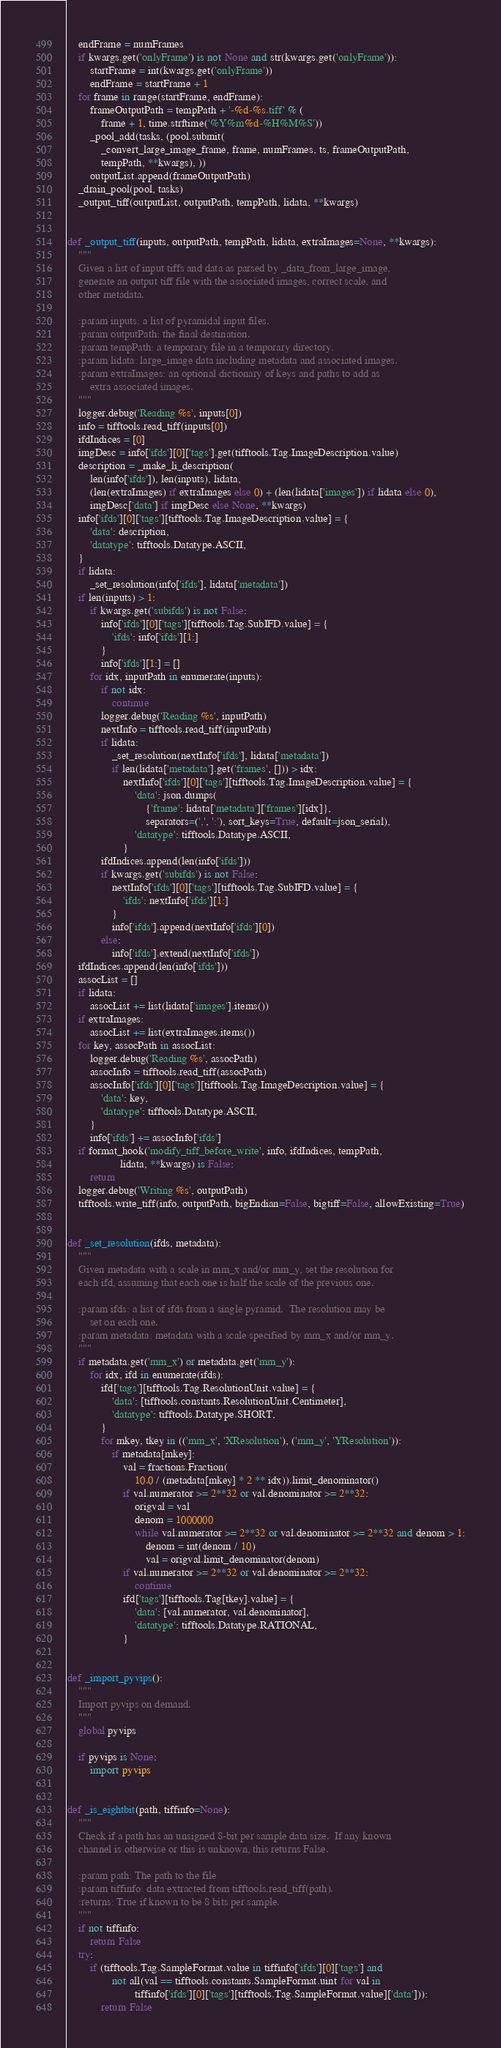Convert code to text. <code><loc_0><loc_0><loc_500><loc_500><_Python_>    endFrame = numFrames
    if kwargs.get('onlyFrame') is not None and str(kwargs.get('onlyFrame')):
        startFrame = int(kwargs.get('onlyFrame'))
        endFrame = startFrame + 1
    for frame in range(startFrame, endFrame):
        frameOutputPath = tempPath + '-%d-%s.tiff' % (
            frame + 1, time.strftime('%Y%m%d-%H%M%S'))
        _pool_add(tasks, (pool.submit(
            _convert_large_image_frame, frame, numFrames, ts, frameOutputPath,
            tempPath, **kwargs), ))
        outputList.append(frameOutputPath)
    _drain_pool(pool, tasks)
    _output_tiff(outputList, outputPath, tempPath, lidata, **kwargs)


def _output_tiff(inputs, outputPath, tempPath, lidata, extraImages=None, **kwargs):
    """
    Given a list of input tiffs and data as parsed by _data_from_large_image,
    generate an output tiff file with the associated images, correct scale, and
    other metadata.

    :param inputs: a list of pyramidal input files.
    :param outputPath: the final destination.
    :param tempPath: a temporary file in a temporary directory.
    :param lidata: large_image data including metadata and associated images.
    :param extraImages: an optional dictionary of keys and paths to add as
        extra associated images.
    """
    logger.debug('Reading %s', inputs[0])
    info = tifftools.read_tiff(inputs[0])
    ifdIndices = [0]
    imgDesc = info['ifds'][0]['tags'].get(tifftools.Tag.ImageDescription.value)
    description = _make_li_description(
        len(info['ifds']), len(inputs), lidata,
        (len(extraImages) if extraImages else 0) + (len(lidata['images']) if lidata else 0),
        imgDesc['data'] if imgDesc else None, **kwargs)
    info['ifds'][0]['tags'][tifftools.Tag.ImageDescription.value] = {
        'data': description,
        'datatype': tifftools.Datatype.ASCII,
    }
    if lidata:
        _set_resolution(info['ifds'], lidata['metadata'])
    if len(inputs) > 1:
        if kwargs.get('subifds') is not False:
            info['ifds'][0]['tags'][tifftools.Tag.SubIFD.value] = {
                'ifds': info['ifds'][1:]
            }
            info['ifds'][1:] = []
        for idx, inputPath in enumerate(inputs):
            if not idx:
                continue
            logger.debug('Reading %s', inputPath)
            nextInfo = tifftools.read_tiff(inputPath)
            if lidata:
                _set_resolution(nextInfo['ifds'], lidata['metadata'])
                if len(lidata['metadata'].get('frames', [])) > idx:
                    nextInfo['ifds'][0]['tags'][tifftools.Tag.ImageDescription.value] = {
                        'data': json.dumps(
                            {'frame': lidata['metadata']['frames'][idx]},
                            separators=(',', ':'), sort_keys=True, default=json_serial),
                        'datatype': tifftools.Datatype.ASCII,
                    }
            ifdIndices.append(len(info['ifds']))
            if kwargs.get('subifds') is not False:
                nextInfo['ifds'][0]['tags'][tifftools.Tag.SubIFD.value] = {
                    'ifds': nextInfo['ifds'][1:]
                }
                info['ifds'].append(nextInfo['ifds'][0])
            else:
                info['ifds'].extend(nextInfo['ifds'])
    ifdIndices.append(len(info['ifds']))
    assocList = []
    if lidata:
        assocList += list(lidata['images'].items())
    if extraImages:
        assocList += list(extraImages.items())
    for key, assocPath in assocList:
        logger.debug('Reading %s', assocPath)
        assocInfo = tifftools.read_tiff(assocPath)
        assocInfo['ifds'][0]['tags'][tifftools.Tag.ImageDescription.value] = {
            'data': key,
            'datatype': tifftools.Datatype.ASCII,
        }
        info['ifds'] += assocInfo['ifds']
    if format_hook('modify_tiff_before_write', info, ifdIndices, tempPath,
                   lidata, **kwargs) is False:
        return
    logger.debug('Writing %s', outputPath)
    tifftools.write_tiff(info, outputPath, bigEndian=False, bigtiff=False, allowExisting=True)


def _set_resolution(ifds, metadata):
    """
    Given metadata with a scale in mm_x and/or mm_y, set the resolution for
    each ifd, assuming that each one is half the scale of the previous one.

    :param ifds: a list of ifds from a single pyramid.  The resolution may be
        set on each one.
    :param metadata: metadata with a scale specified by mm_x and/or mm_y.
    """
    if metadata.get('mm_x') or metadata.get('mm_y'):
        for idx, ifd in enumerate(ifds):
            ifd['tags'][tifftools.Tag.ResolutionUnit.value] = {
                'data': [tifftools.constants.ResolutionUnit.Centimeter],
                'datatype': tifftools.Datatype.SHORT,
            }
            for mkey, tkey in (('mm_x', 'XResolution'), ('mm_y', 'YResolution')):
                if metadata[mkey]:
                    val = fractions.Fraction(
                        10.0 / (metadata[mkey] * 2 ** idx)).limit_denominator()
                    if val.numerator >= 2**32 or val.denominator >= 2**32:
                        origval = val
                        denom = 1000000
                        while val.numerator >= 2**32 or val.denominator >= 2**32 and denom > 1:
                            denom = int(denom / 10)
                            val = origval.limit_denominator(denom)
                    if val.numerator >= 2**32 or val.denominator >= 2**32:
                        continue
                    ifd['tags'][tifftools.Tag[tkey].value] = {
                        'data': [val.numerator, val.denominator],
                        'datatype': tifftools.Datatype.RATIONAL,
                    }


def _import_pyvips():
    """
    Import pyvips on demand.
    """
    global pyvips

    if pyvips is None:
        import pyvips


def _is_eightbit(path, tiffinfo=None):
    """
    Check if a path has an unsigned 8-bit per sample data size.  If any known
    channel is otherwise or this is unknown, this returns False.

    :param path: The path to the file
    :param tiffinfo: data extracted from tifftools.read_tiff(path).
    :returns: True if known to be 8 bits per sample.
    """
    if not tiffinfo:
        return False
    try:
        if (tifftools.Tag.SampleFormat.value in tiffinfo['ifds'][0]['tags'] and
                not all(val == tifftools.constants.SampleFormat.uint for val in
                        tiffinfo['ifds'][0]['tags'][tifftools.Tag.SampleFormat.value]['data'])):
            return False</code> 